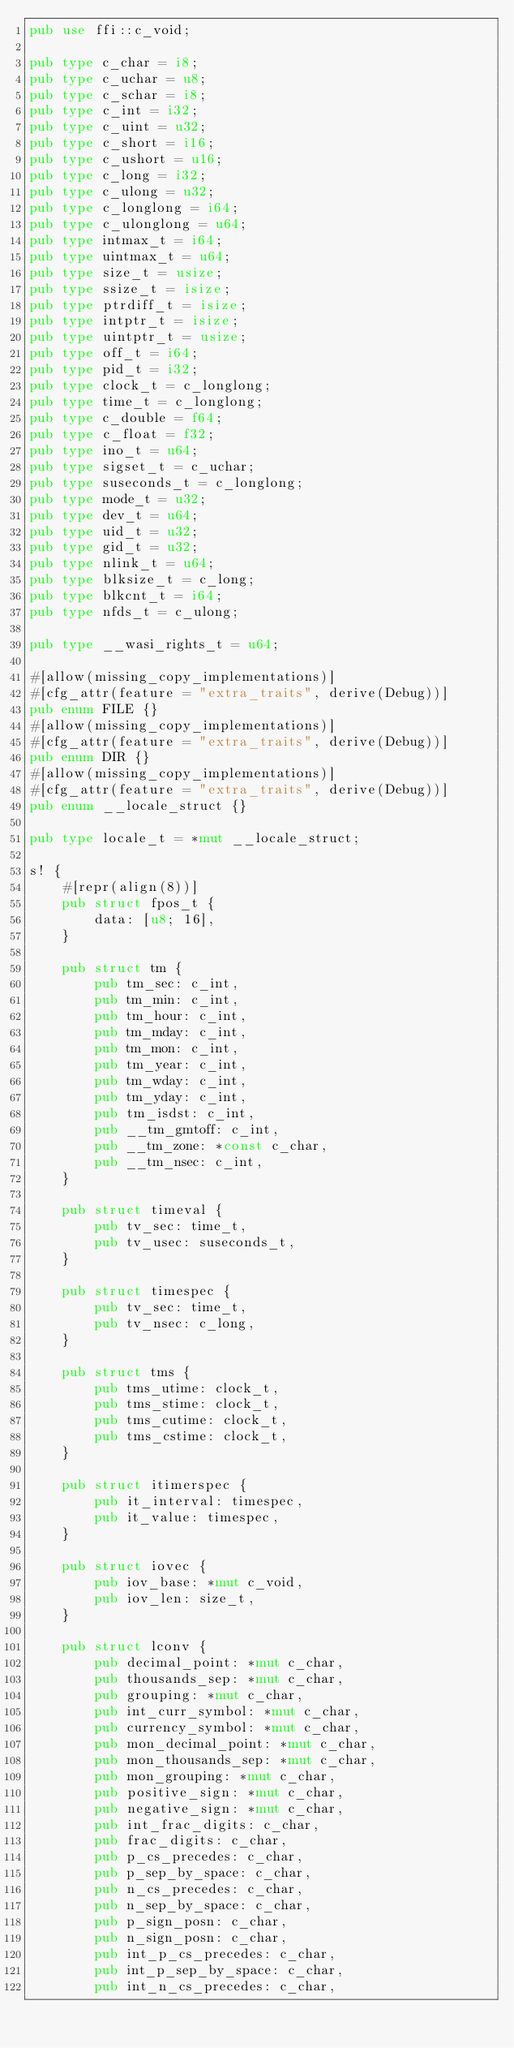Convert code to text. <code><loc_0><loc_0><loc_500><loc_500><_Rust_>pub use ffi::c_void;

pub type c_char = i8;
pub type c_uchar = u8;
pub type c_schar = i8;
pub type c_int = i32;
pub type c_uint = u32;
pub type c_short = i16;
pub type c_ushort = u16;
pub type c_long = i32;
pub type c_ulong = u32;
pub type c_longlong = i64;
pub type c_ulonglong = u64;
pub type intmax_t = i64;
pub type uintmax_t = u64;
pub type size_t = usize;
pub type ssize_t = isize;
pub type ptrdiff_t = isize;
pub type intptr_t = isize;
pub type uintptr_t = usize;
pub type off_t = i64;
pub type pid_t = i32;
pub type clock_t = c_longlong;
pub type time_t = c_longlong;
pub type c_double = f64;
pub type c_float = f32;
pub type ino_t = u64;
pub type sigset_t = c_uchar;
pub type suseconds_t = c_longlong;
pub type mode_t = u32;
pub type dev_t = u64;
pub type uid_t = u32;
pub type gid_t = u32;
pub type nlink_t = u64;
pub type blksize_t = c_long;
pub type blkcnt_t = i64;
pub type nfds_t = c_ulong;

pub type __wasi_rights_t = u64;

#[allow(missing_copy_implementations)]
#[cfg_attr(feature = "extra_traits", derive(Debug))]
pub enum FILE {}
#[allow(missing_copy_implementations)]
#[cfg_attr(feature = "extra_traits", derive(Debug))]
pub enum DIR {}
#[allow(missing_copy_implementations)]
#[cfg_attr(feature = "extra_traits", derive(Debug))]
pub enum __locale_struct {}

pub type locale_t = *mut __locale_struct;

s! {
    #[repr(align(8))]
    pub struct fpos_t {
        data: [u8; 16],
    }

    pub struct tm {
        pub tm_sec: c_int,
        pub tm_min: c_int,
        pub tm_hour: c_int,
        pub tm_mday: c_int,
        pub tm_mon: c_int,
        pub tm_year: c_int,
        pub tm_wday: c_int,
        pub tm_yday: c_int,
        pub tm_isdst: c_int,
        pub __tm_gmtoff: c_int,
        pub __tm_zone: *const c_char,
        pub __tm_nsec: c_int,
    }

    pub struct timeval {
        pub tv_sec: time_t,
        pub tv_usec: suseconds_t,
    }

    pub struct timespec {
        pub tv_sec: time_t,
        pub tv_nsec: c_long,
    }

    pub struct tms {
        pub tms_utime: clock_t,
        pub tms_stime: clock_t,
        pub tms_cutime: clock_t,
        pub tms_cstime: clock_t,
    }

    pub struct itimerspec {
        pub it_interval: timespec,
        pub it_value: timespec,
    }

    pub struct iovec {
        pub iov_base: *mut c_void,
        pub iov_len: size_t,
    }

    pub struct lconv {
        pub decimal_point: *mut c_char,
        pub thousands_sep: *mut c_char,
        pub grouping: *mut c_char,
        pub int_curr_symbol: *mut c_char,
        pub currency_symbol: *mut c_char,
        pub mon_decimal_point: *mut c_char,
        pub mon_thousands_sep: *mut c_char,
        pub mon_grouping: *mut c_char,
        pub positive_sign: *mut c_char,
        pub negative_sign: *mut c_char,
        pub int_frac_digits: c_char,
        pub frac_digits: c_char,
        pub p_cs_precedes: c_char,
        pub p_sep_by_space: c_char,
        pub n_cs_precedes: c_char,
        pub n_sep_by_space: c_char,
        pub p_sign_posn: c_char,
        pub n_sign_posn: c_char,
        pub int_p_cs_precedes: c_char,
        pub int_p_sep_by_space: c_char,
        pub int_n_cs_precedes: c_char,</code> 